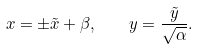Convert formula to latex. <formula><loc_0><loc_0><loc_500><loc_500>x = \pm \tilde { x } + \beta , \quad y = \frac { \tilde { y } } { \sqrt { \alpha } } .</formula> 